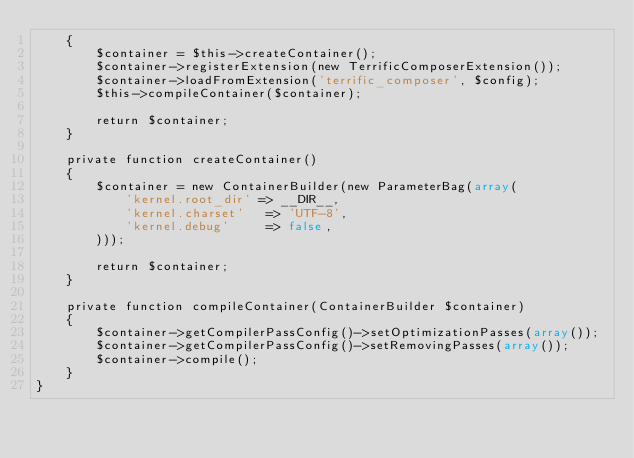Convert code to text. <code><loc_0><loc_0><loc_500><loc_500><_PHP_>    {
        $container = $this->createContainer();
        $container->registerExtension(new TerrificComposerExtension());
        $container->loadFromExtension('terrific_composer', $config);
        $this->compileContainer($container);

        return $container;
    }

    private function createContainer()
    {
        $container = new ContainerBuilder(new ParameterBag(array(
            'kernel.root_dir' => __DIR__,
            'kernel.charset'   => 'UTF-8',
            'kernel.debug'     => false,
        )));

        return $container;
    }

    private function compileContainer(ContainerBuilder $container)
    {
        $container->getCompilerPassConfig()->setOptimizationPasses(array());
        $container->getCompilerPassConfig()->setRemovingPasses(array());
        $container->compile();
    }
}</code> 